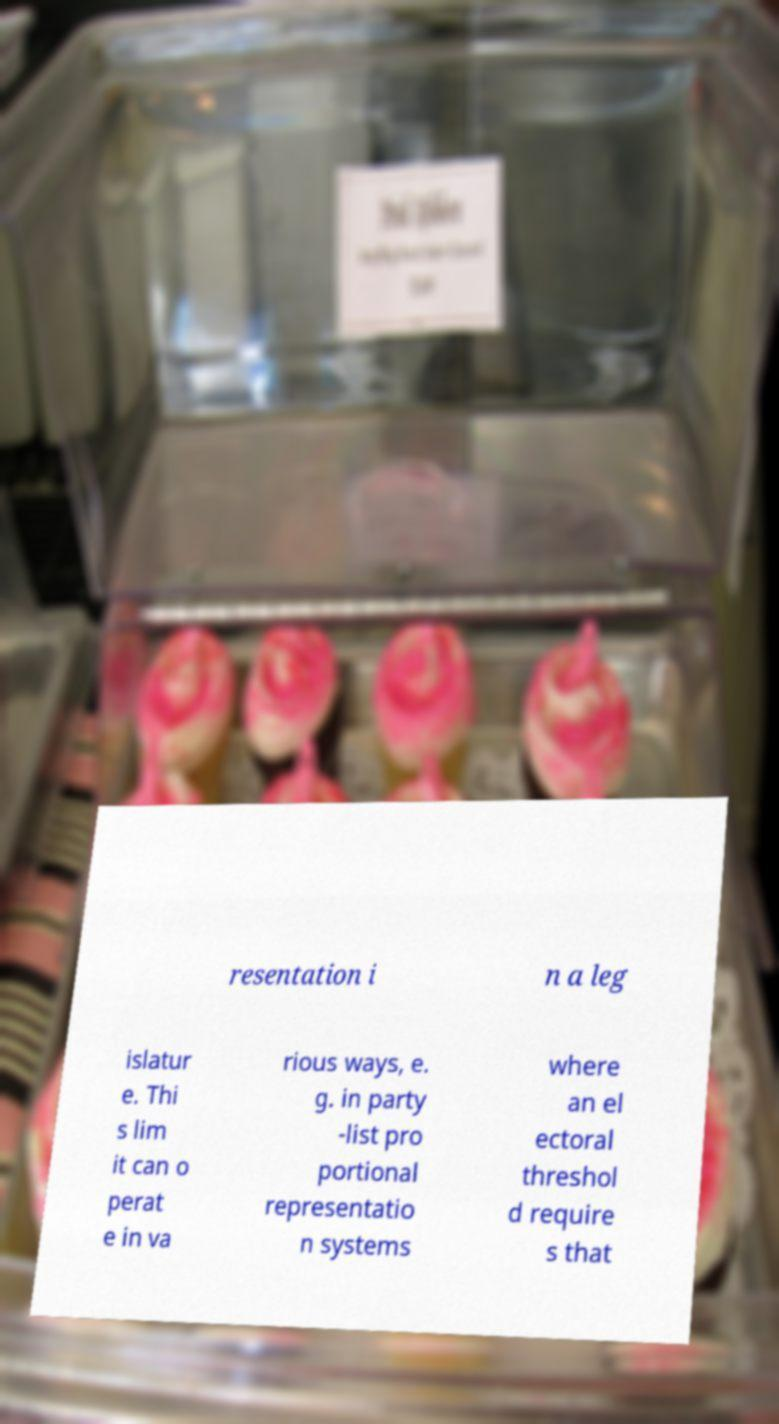Please identify and transcribe the text found in this image. resentation i n a leg islatur e. Thi s lim it can o perat e in va rious ways, e. g. in party -list pro portional representatio n systems where an el ectoral threshol d require s that 